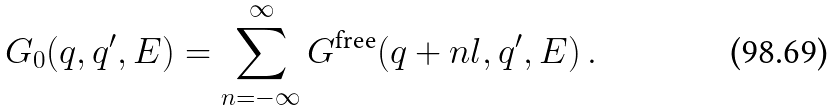Convert formula to latex. <formula><loc_0><loc_0><loc_500><loc_500>G _ { 0 } ( q , q ^ { \prime } , E ) = \sum _ { n = - \infty } ^ { \infty } G ^ { \text {free} } ( q + n l , q ^ { \prime } , E ) \, .</formula> 